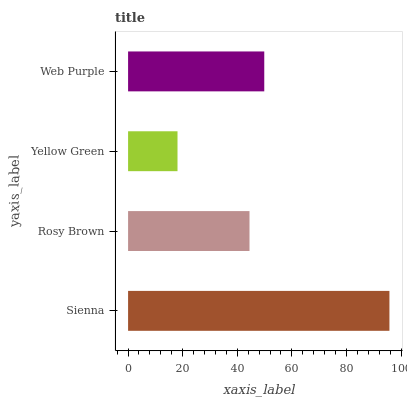Is Yellow Green the minimum?
Answer yes or no. Yes. Is Sienna the maximum?
Answer yes or no. Yes. Is Rosy Brown the minimum?
Answer yes or no. No. Is Rosy Brown the maximum?
Answer yes or no. No. Is Sienna greater than Rosy Brown?
Answer yes or no. Yes. Is Rosy Brown less than Sienna?
Answer yes or no. Yes. Is Rosy Brown greater than Sienna?
Answer yes or no. No. Is Sienna less than Rosy Brown?
Answer yes or no. No. Is Web Purple the high median?
Answer yes or no. Yes. Is Rosy Brown the low median?
Answer yes or no. Yes. Is Yellow Green the high median?
Answer yes or no. No. Is Sienna the low median?
Answer yes or no. No. 